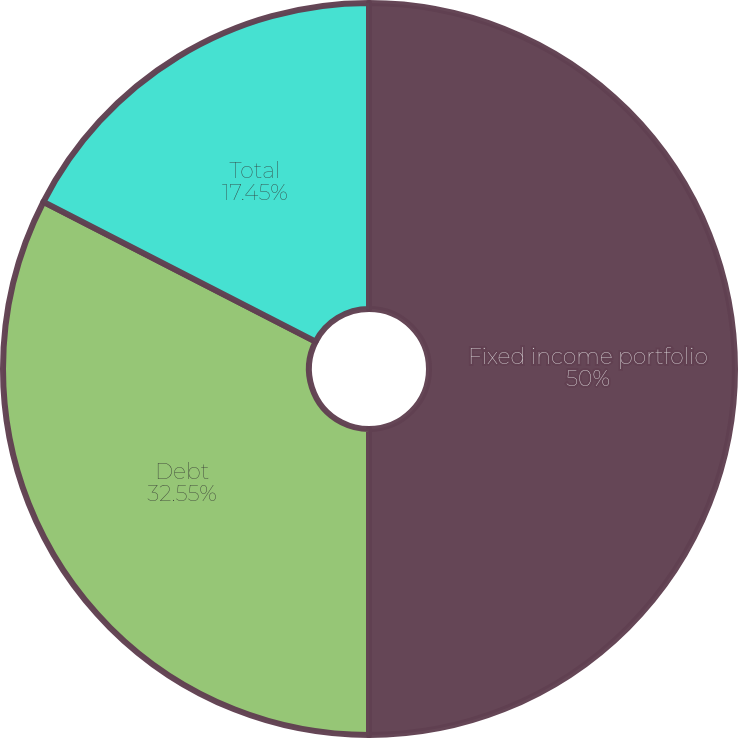Convert chart. <chart><loc_0><loc_0><loc_500><loc_500><pie_chart><fcel>Fixed income portfolio<fcel>Debt<fcel>Total<nl><fcel>50.0%<fcel>32.55%<fcel>17.45%<nl></chart> 